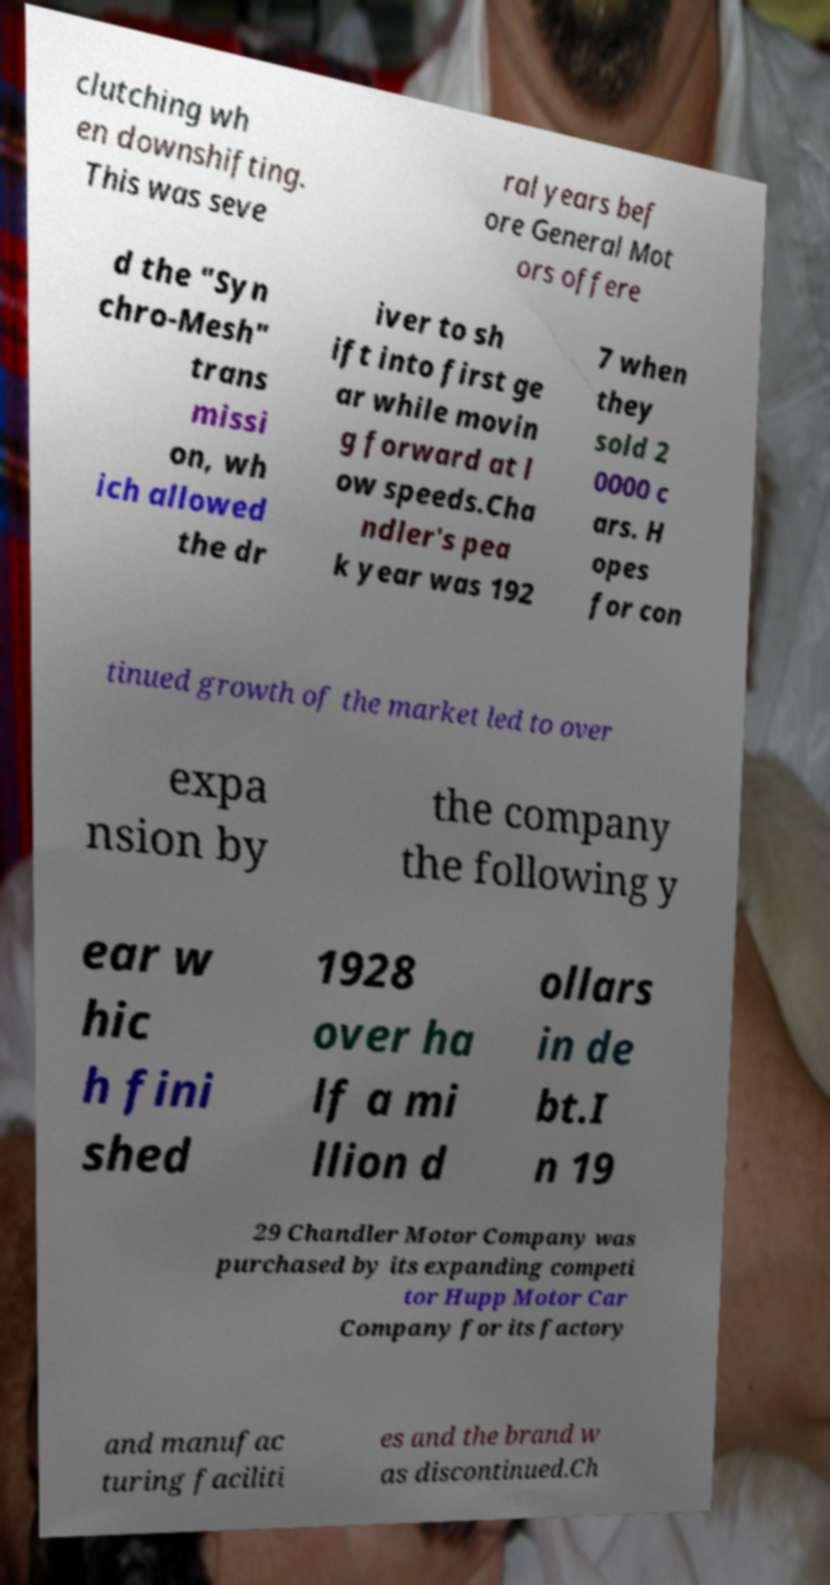For documentation purposes, I need the text within this image transcribed. Could you provide that? clutching wh en downshifting. This was seve ral years bef ore General Mot ors offere d the "Syn chro-Mesh" trans missi on, wh ich allowed the dr iver to sh ift into first ge ar while movin g forward at l ow speeds.Cha ndler's pea k year was 192 7 when they sold 2 0000 c ars. H opes for con tinued growth of the market led to over expa nsion by the company the following y ear w hic h fini shed 1928 over ha lf a mi llion d ollars in de bt.I n 19 29 Chandler Motor Company was purchased by its expanding competi tor Hupp Motor Car Company for its factory and manufac turing faciliti es and the brand w as discontinued.Ch 